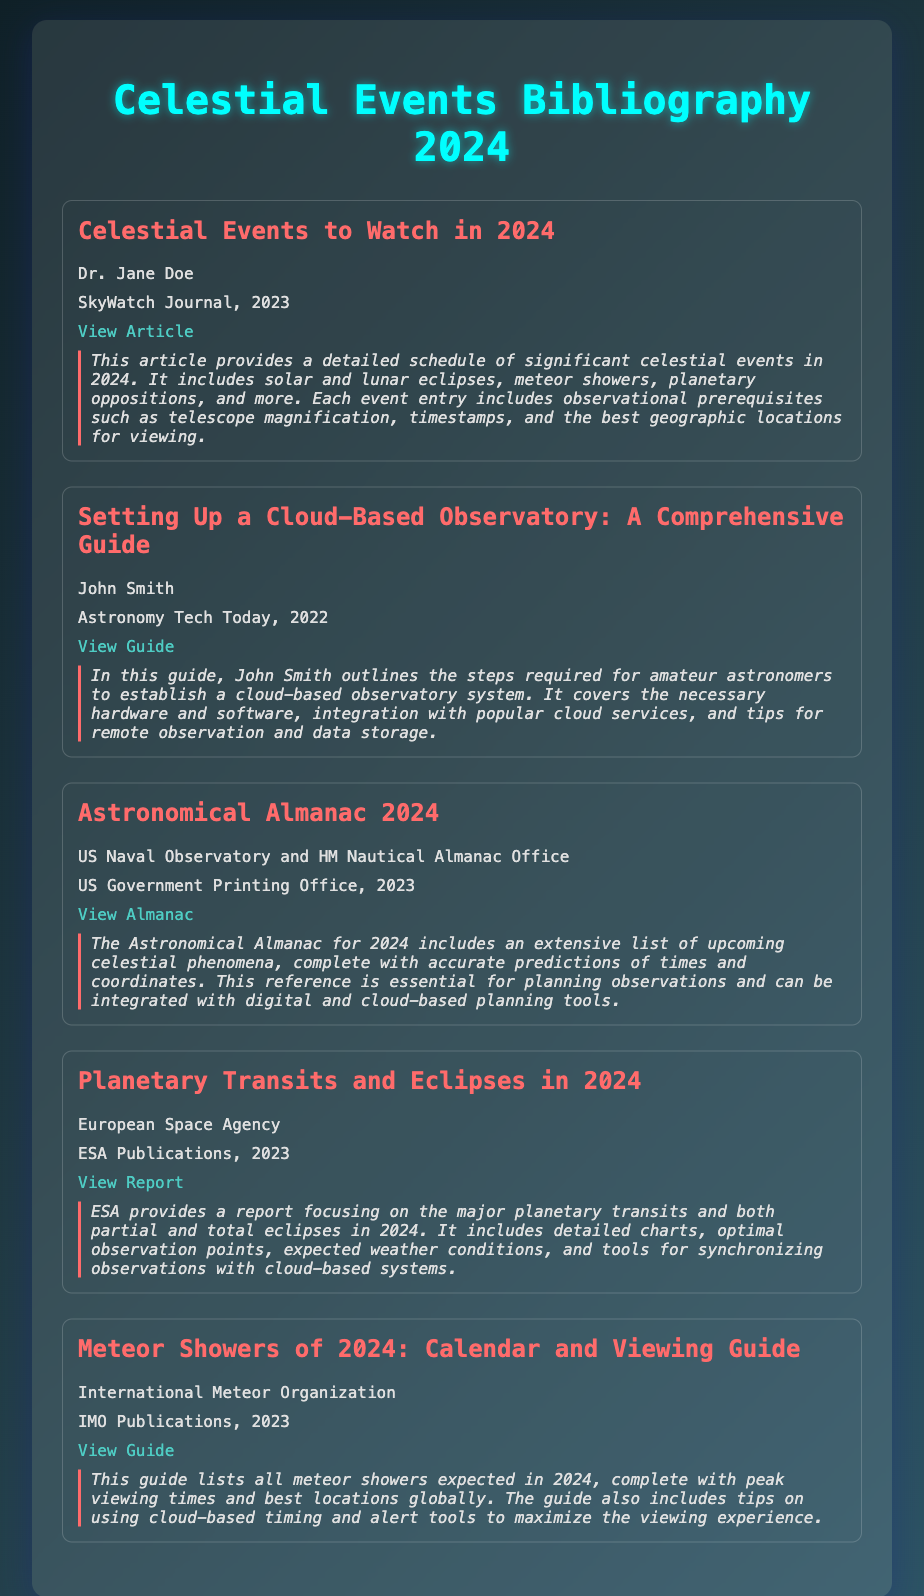What is the title of the first entry? The title is the name of the document's first entry listed under the header.
Answer: Celestial Events to Watch in 2024 Who is the author of the second entry? The author is mentioned alongside the title and publication information in the entry.
Answer: John Smith What publication year is the "Astronomical Almanac" from? The publication year is indicated beneath the title and author in the entry.
Answer: 2023 How many celestial events are covered in the first entry? The description provides an overview of the types of events included in that specific entry.
Answer: Significant celestial events Which organization published the guide on meteor showers? The organization is identified right after the title in the entry listing.
Answer: International Meteor Organization What major feature is included in the ESA report? The main features are highlighted in the summary of the entry.
Answer: Major planetary transits and both partial and total eclipses What type of tools are mentioned for maximizing the viewing experience in the meteor shower guide? This can be inferred from the section discussing additional features in the entry.
Answer: Cloud-based timing and alert tools What color is used for the title text of the entries? The style used for the title text can be found in the CSS or visual representation of the document.
Answer: #ff6b6b Which celestial event does "Setting Up a Cloud-Based Observatory" focus on? This entry type is inferred from the abstract text, indicating a specific focus area related to observatory setup.
Answer: Establishing a cloud-based observatory system 